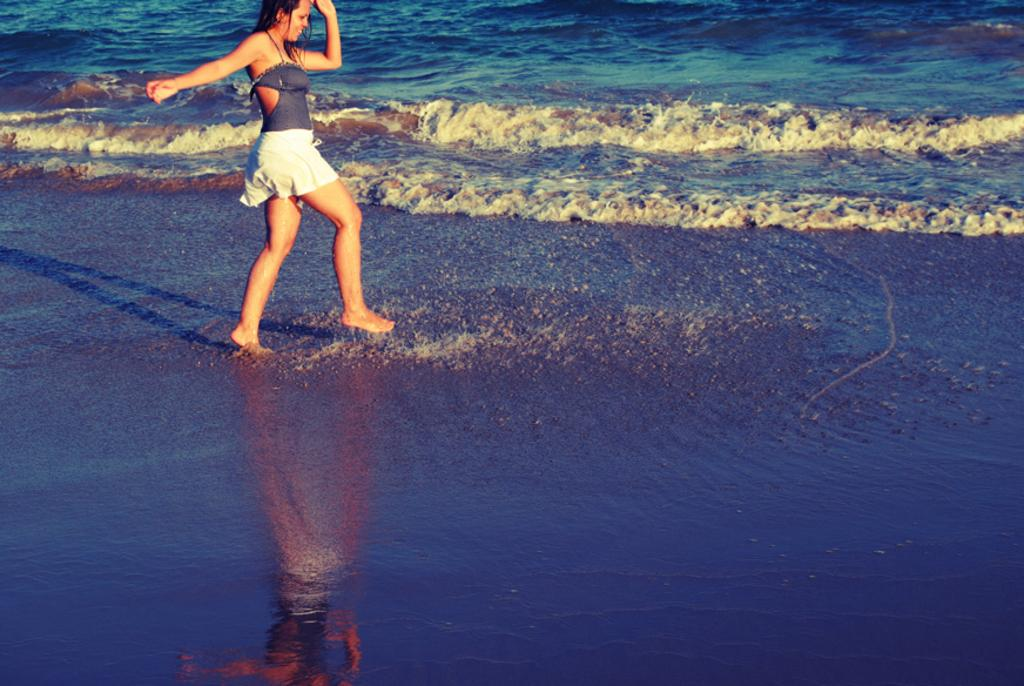What is the person in the image doing? The person is walking in the water. What color is the shirt the person is wearing? The person is wearing a gray shirt. What type of clothing is the person wearing on the bottom? The person is wearing a white skirt. What can be seen in the background of the image? The background of the image includes water. What type of glove is the person wearing in the image? There is no glove visible in the image; the person is wearing a gray shirt and a white skirt. 